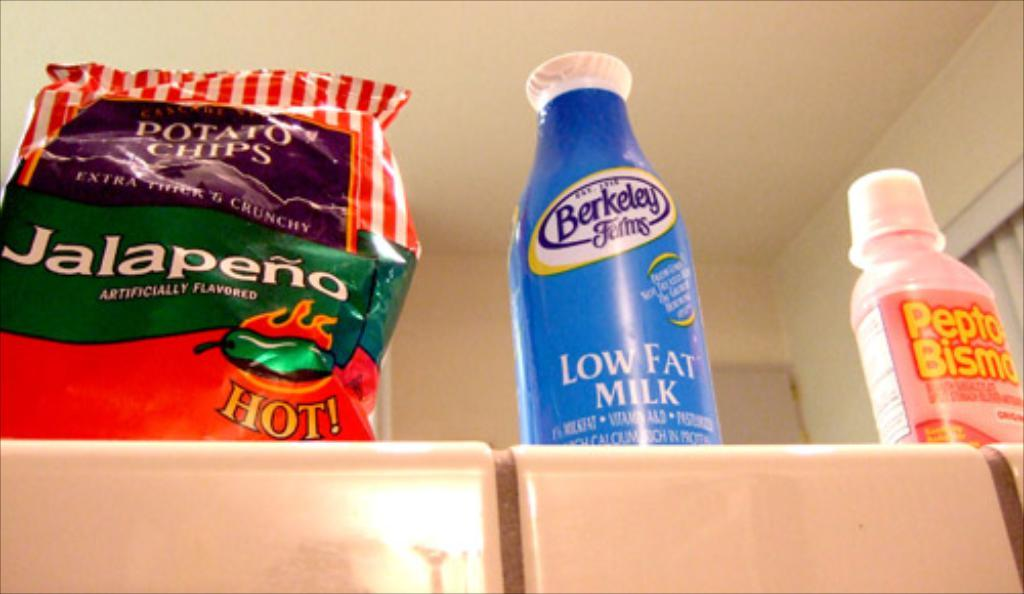<image>
Render a clear and concise summary of the photo. Potato chips, milk and pepto are featured on the counter 